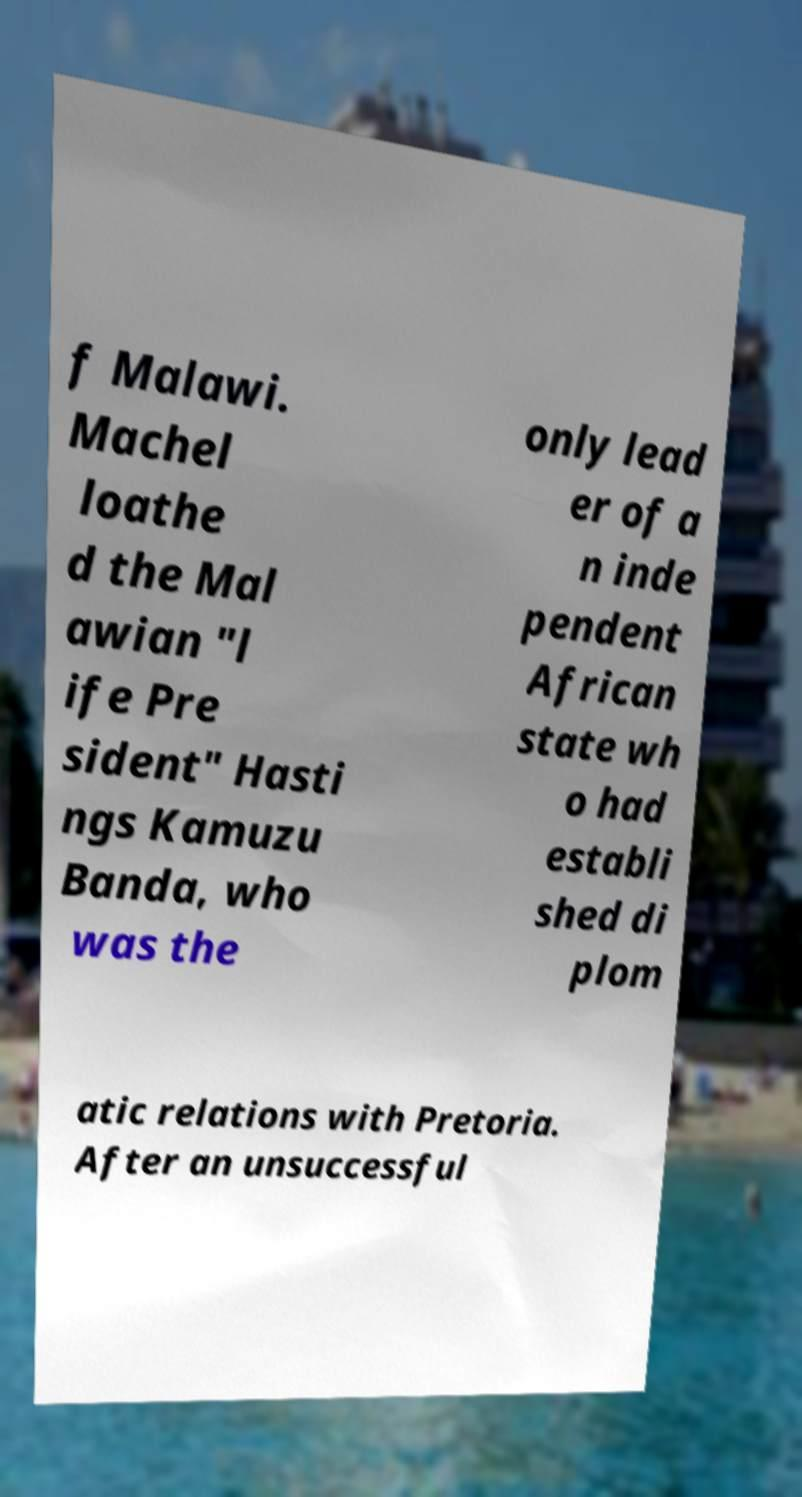Please read and relay the text visible in this image. What does it say? f Malawi. Machel loathe d the Mal awian "l ife Pre sident" Hasti ngs Kamuzu Banda, who was the only lead er of a n inde pendent African state wh o had establi shed di plom atic relations with Pretoria. After an unsuccessful 